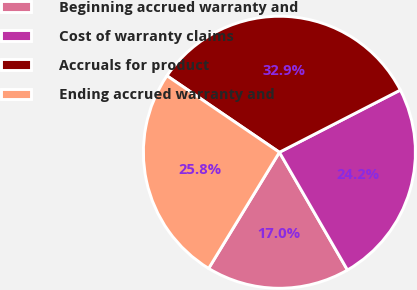<chart> <loc_0><loc_0><loc_500><loc_500><pie_chart><fcel>Beginning accrued warranty and<fcel>Cost of warranty claims<fcel>Accruals for product<fcel>Ending accrued warranty and<nl><fcel>17.05%<fcel>24.22%<fcel>32.93%<fcel>25.8%<nl></chart> 